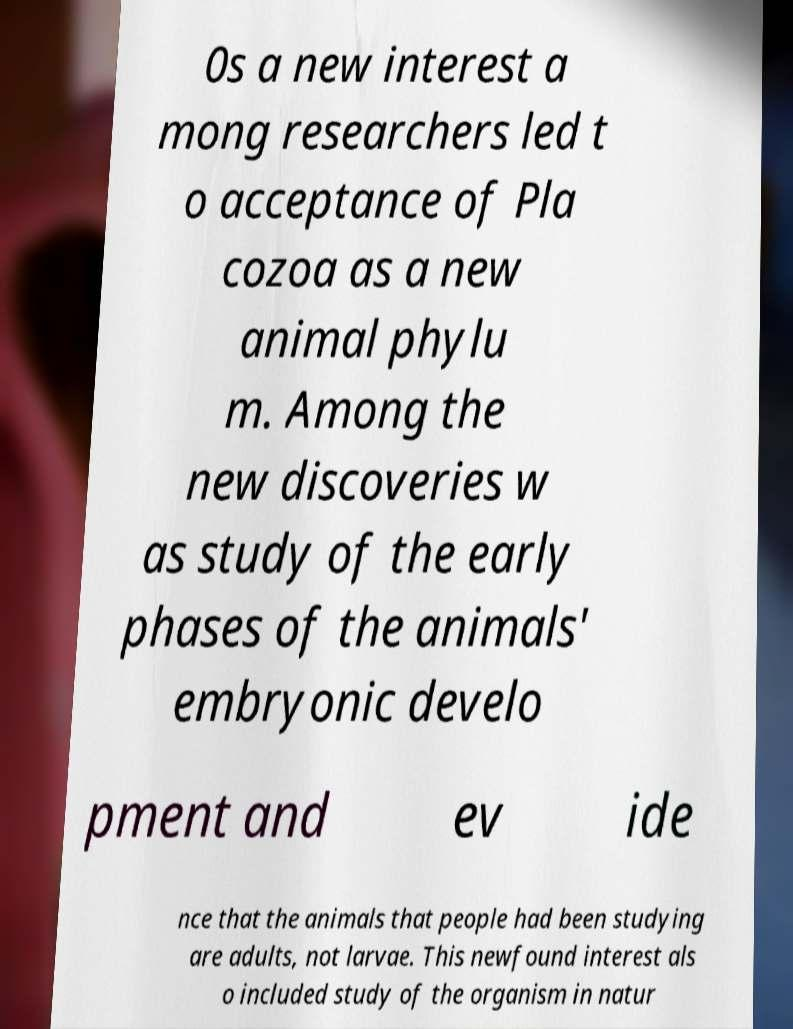Could you assist in decoding the text presented in this image and type it out clearly? 0s a new interest a mong researchers led t o acceptance of Pla cozoa as a new animal phylu m. Among the new discoveries w as study of the early phases of the animals' embryonic develo pment and ev ide nce that the animals that people had been studying are adults, not larvae. This newfound interest als o included study of the organism in natur 